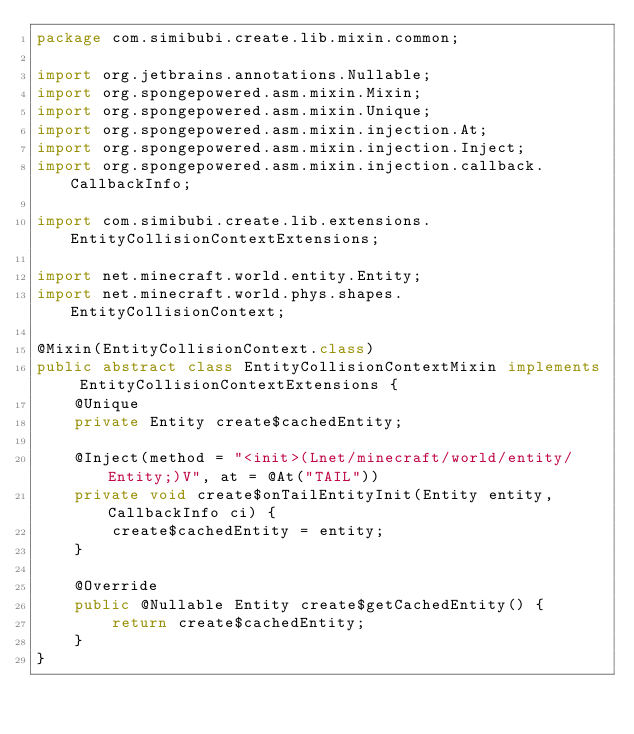<code> <loc_0><loc_0><loc_500><loc_500><_Java_>package com.simibubi.create.lib.mixin.common;

import org.jetbrains.annotations.Nullable;
import org.spongepowered.asm.mixin.Mixin;
import org.spongepowered.asm.mixin.Unique;
import org.spongepowered.asm.mixin.injection.At;
import org.spongepowered.asm.mixin.injection.Inject;
import org.spongepowered.asm.mixin.injection.callback.CallbackInfo;

import com.simibubi.create.lib.extensions.EntityCollisionContextExtensions;

import net.minecraft.world.entity.Entity;
import net.minecraft.world.phys.shapes.EntityCollisionContext;

@Mixin(EntityCollisionContext.class)
public abstract class EntityCollisionContextMixin implements EntityCollisionContextExtensions {
	@Unique
	private Entity create$cachedEntity;

	@Inject(method = "<init>(Lnet/minecraft/world/entity/Entity;)V", at = @At("TAIL"))
	private void create$onTailEntityInit(Entity entity, CallbackInfo ci) {
		create$cachedEntity = entity;
	}

	@Override
	public @Nullable Entity create$getCachedEntity() {
		return create$cachedEntity;
	}
}
</code> 